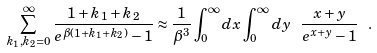<formula> <loc_0><loc_0><loc_500><loc_500>\sum _ { k _ { 1 } , k _ { 2 } = 0 } ^ { \infty } \frac { 1 + k _ { 1 } + k _ { 2 } } { e ^ { \beta ( 1 + k _ { 1 } + k _ { 2 } ) } - 1 } \approx \frac { 1 } { \beta ^ { 3 } } \int _ { 0 } ^ { \infty } d x \int _ { 0 } ^ { \infty } d y \ \frac { x + y } { e ^ { x + y } - 1 } \ .</formula> 